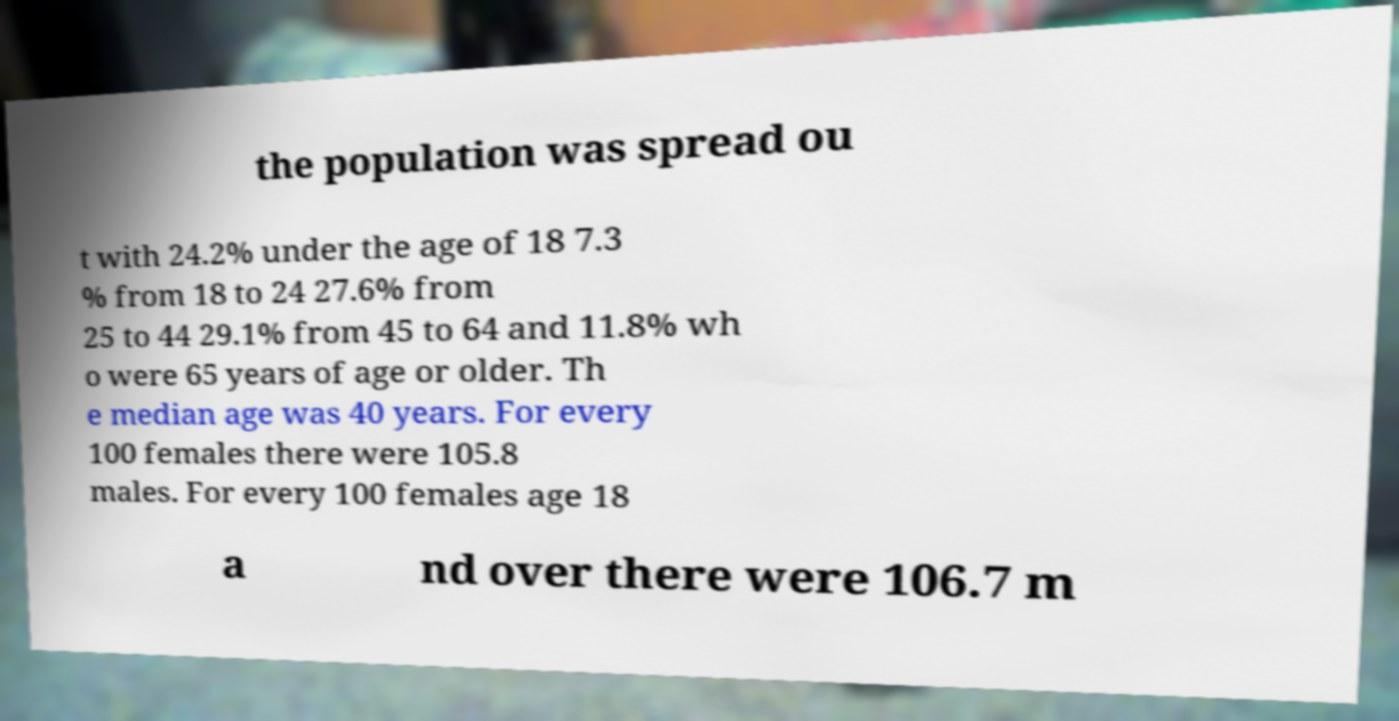Please identify and transcribe the text found in this image. the population was spread ou t with 24.2% under the age of 18 7.3 % from 18 to 24 27.6% from 25 to 44 29.1% from 45 to 64 and 11.8% wh o were 65 years of age or older. Th e median age was 40 years. For every 100 females there were 105.8 males. For every 100 females age 18 a nd over there were 106.7 m 